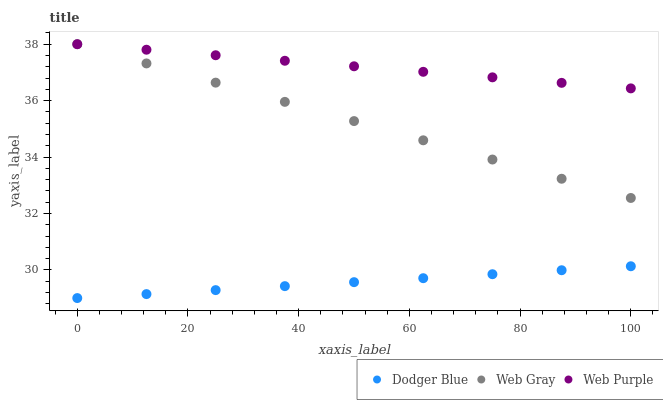Does Dodger Blue have the minimum area under the curve?
Answer yes or no. Yes. Does Web Purple have the maximum area under the curve?
Answer yes or no. Yes. Does Web Gray have the minimum area under the curve?
Answer yes or no. No. Does Web Gray have the maximum area under the curve?
Answer yes or no. No. Is Dodger Blue the smoothest?
Answer yes or no. Yes. Is Web Gray the roughest?
Answer yes or no. Yes. Is Web Gray the smoothest?
Answer yes or no. No. Is Dodger Blue the roughest?
Answer yes or no. No. Does Dodger Blue have the lowest value?
Answer yes or no. Yes. Does Web Gray have the lowest value?
Answer yes or no. No. Does Web Gray have the highest value?
Answer yes or no. Yes. Does Dodger Blue have the highest value?
Answer yes or no. No. Is Dodger Blue less than Web Gray?
Answer yes or no. Yes. Is Web Gray greater than Dodger Blue?
Answer yes or no. Yes. Does Web Gray intersect Web Purple?
Answer yes or no. Yes. Is Web Gray less than Web Purple?
Answer yes or no. No. Is Web Gray greater than Web Purple?
Answer yes or no. No. Does Dodger Blue intersect Web Gray?
Answer yes or no. No. 